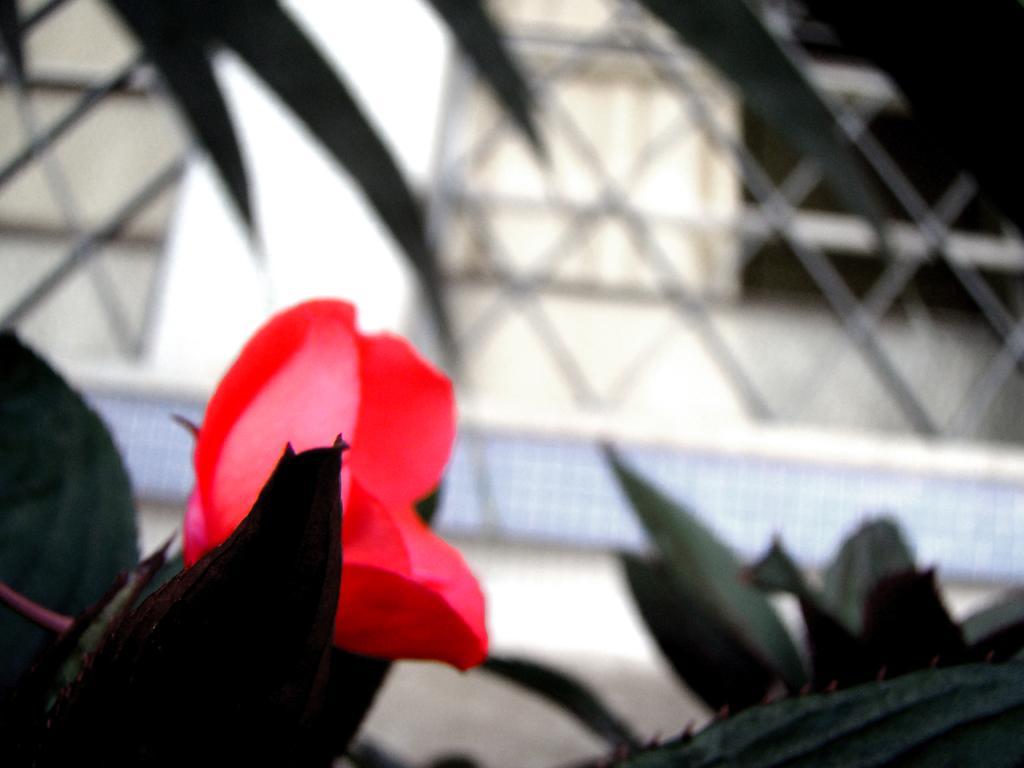Describe this image in one or two sentences. This is a zoomed in picture. In the foreground there are some objects seems to be the plants and there is a red color object seems to be the flower. The background of the image is blurry and we can see the metal rods and some other items in the background. 